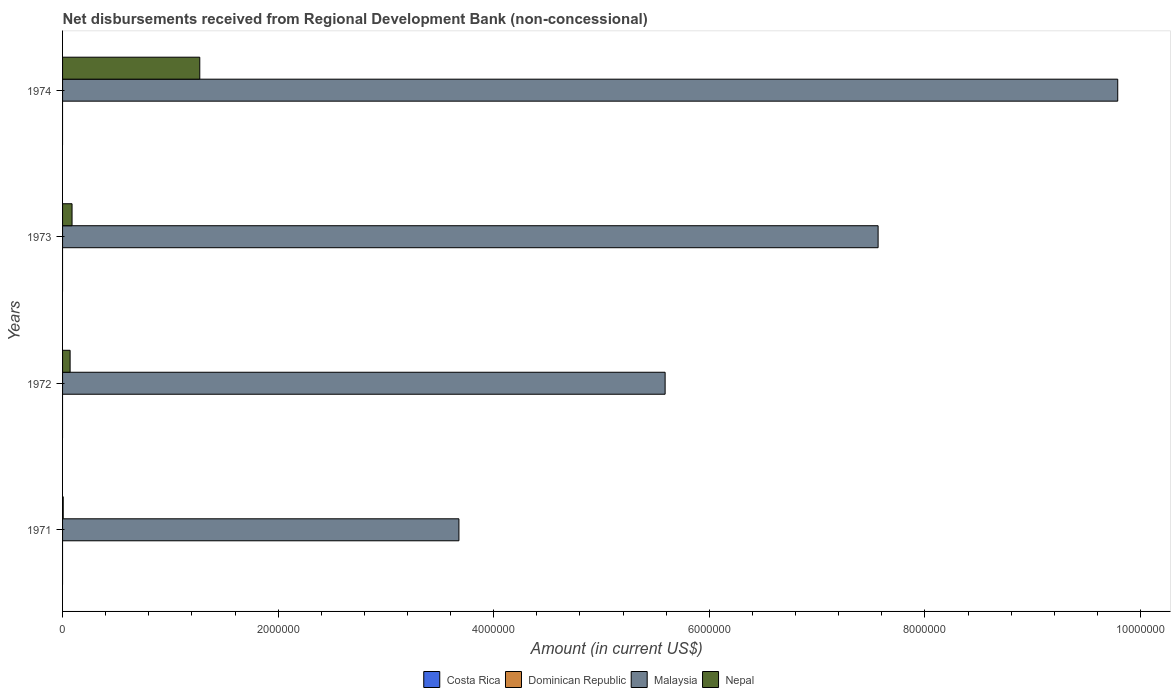How many bars are there on the 1st tick from the top?
Offer a very short reply. 2. What is the label of the 1st group of bars from the top?
Provide a short and direct response. 1974. What is the amount of disbursements received from Regional Development Bank in Nepal in 1972?
Make the answer very short. 7.00e+04. Across all years, what is the maximum amount of disbursements received from Regional Development Bank in Malaysia?
Give a very brief answer. 9.79e+06. Across all years, what is the minimum amount of disbursements received from Regional Development Bank in Costa Rica?
Give a very brief answer. 0. In which year was the amount of disbursements received from Regional Development Bank in Malaysia maximum?
Ensure brevity in your answer.  1974. What is the total amount of disbursements received from Regional Development Bank in Malaysia in the graph?
Your answer should be very brief. 2.66e+07. What is the difference between the amount of disbursements received from Regional Development Bank in Nepal in 1971 and that in 1974?
Your response must be concise. -1.27e+06. What is the difference between the amount of disbursements received from Regional Development Bank in Malaysia in 1971 and the amount of disbursements received from Regional Development Bank in Dominican Republic in 1972?
Give a very brief answer. 3.68e+06. What is the average amount of disbursements received from Regional Development Bank in Malaysia per year?
Give a very brief answer. 6.66e+06. In the year 1971, what is the difference between the amount of disbursements received from Regional Development Bank in Malaysia and amount of disbursements received from Regional Development Bank in Nepal?
Give a very brief answer. 3.67e+06. In how many years, is the amount of disbursements received from Regional Development Bank in Malaysia greater than 800000 US$?
Your answer should be very brief. 4. What is the ratio of the amount of disbursements received from Regional Development Bank in Nepal in 1972 to that in 1973?
Make the answer very short. 0.8. Is the amount of disbursements received from Regional Development Bank in Nepal in 1972 less than that in 1974?
Give a very brief answer. Yes. What is the difference between the highest and the second highest amount of disbursements received from Regional Development Bank in Nepal?
Keep it short and to the point. 1.18e+06. What is the difference between the highest and the lowest amount of disbursements received from Regional Development Bank in Nepal?
Your response must be concise. 1.27e+06. In how many years, is the amount of disbursements received from Regional Development Bank in Malaysia greater than the average amount of disbursements received from Regional Development Bank in Malaysia taken over all years?
Your response must be concise. 2. Is the sum of the amount of disbursements received from Regional Development Bank in Nepal in 1972 and 1974 greater than the maximum amount of disbursements received from Regional Development Bank in Dominican Republic across all years?
Ensure brevity in your answer.  Yes. Is it the case that in every year, the sum of the amount of disbursements received from Regional Development Bank in Dominican Republic and amount of disbursements received from Regional Development Bank in Nepal is greater than the amount of disbursements received from Regional Development Bank in Costa Rica?
Provide a succinct answer. Yes. How many years are there in the graph?
Give a very brief answer. 4. Does the graph contain grids?
Offer a very short reply. No. Where does the legend appear in the graph?
Give a very brief answer. Bottom center. What is the title of the graph?
Keep it short and to the point. Net disbursements received from Regional Development Bank (non-concessional). What is the Amount (in current US$) of Malaysia in 1971?
Give a very brief answer. 3.68e+06. What is the Amount (in current US$) in Nepal in 1971?
Ensure brevity in your answer.  6000. What is the Amount (in current US$) of Malaysia in 1972?
Keep it short and to the point. 5.59e+06. What is the Amount (in current US$) in Malaysia in 1973?
Provide a succinct answer. 7.57e+06. What is the Amount (in current US$) of Nepal in 1973?
Your response must be concise. 8.80e+04. What is the Amount (in current US$) of Costa Rica in 1974?
Ensure brevity in your answer.  0. What is the Amount (in current US$) in Malaysia in 1974?
Offer a very short reply. 9.79e+06. What is the Amount (in current US$) of Nepal in 1974?
Offer a very short reply. 1.27e+06. Across all years, what is the maximum Amount (in current US$) in Malaysia?
Your answer should be very brief. 9.79e+06. Across all years, what is the maximum Amount (in current US$) of Nepal?
Give a very brief answer. 1.27e+06. Across all years, what is the minimum Amount (in current US$) in Malaysia?
Provide a short and direct response. 3.68e+06. Across all years, what is the minimum Amount (in current US$) in Nepal?
Your answer should be very brief. 6000. What is the total Amount (in current US$) of Dominican Republic in the graph?
Offer a terse response. 0. What is the total Amount (in current US$) in Malaysia in the graph?
Your answer should be compact. 2.66e+07. What is the total Amount (in current US$) in Nepal in the graph?
Offer a terse response. 1.44e+06. What is the difference between the Amount (in current US$) in Malaysia in 1971 and that in 1972?
Give a very brief answer. -1.91e+06. What is the difference between the Amount (in current US$) of Nepal in 1971 and that in 1972?
Provide a succinct answer. -6.40e+04. What is the difference between the Amount (in current US$) in Malaysia in 1971 and that in 1973?
Your response must be concise. -3.89e+06. What is the difference between the Amount (in current US$) of Nepal in 1971 and that in 1973?
Offer a terse response. -8.20e+04. What is the difference between the Amount (in current US$) of Malaysia in 1971 and that in 1974?
Your answer should be very brief. -6.11e+06. What is the difference between the Amount (in current US$) in Nepal in 1971 and that in 1974?
Your answer should be very brief. -1.27e+06. What is the difference between the Amount (in current US$) of Malaysia in 1972 and that in 1973?
Your response must be concise. -1.98e+06. What is the difference between the Amount (in current US$) of Nepal in 1972 and that in 1973?
Provide a short and direct response. -1.80e+04. What is the difference between the Amount (in current US$) of Malaysia in 1972 and that in 1974?
Provide a succinct answer. -4.20e+06. What is the difference between the Amount (in current US$) in Nepal in 1972 and that in 1974?
Your answer should be compact. -1.20e+06. What is the difference between the Amount (in current US$) in Malaysia in 1973 and that in 1974?
Your response must be concise. -2.22e+06. What is the difference between the Amount (in current US$) of Nepal in 1973 and that in 1974?
Your response must be concise. -1.18e+06. What is the difference between the Amount (in current US$) of Malaysia in 1971 and the Amount (in current US$) of Nepal in 1972?
Offer a very short reply. 3.61e+06. What is the difference between the Amount (in current US$) of Malaysia in 1971 and the Amount (in current US$) of Nepal in 1973?
Provide a short and direct response. 3.59e+06. What is the difference between the Amount (in current US$) of Malaysia in 1971 and the Amount (in current US$) of Nepal in 1974?
Ensure brevity in your answer.  2.40e+06. What is the difference between the Amount (in current US$) in Malaysia in 1972 and the Amount (in current US$) in Nepal in 1973?
Provide a succinct answer. 5.50e+06. What is the difference between the Amount (in current US$) of Malaysia in 1972 and the Amount (in current US$) of Nepal in 1974?
Your response must be concise. 4.32e+06. What is the difference between the Amount (in current US$) in Malaysia in 1973 and the Amount (in current US$) in Nepal in 1974?
Keep it short and to the point. 6.29e+06. What is the average Amount (in current US$) of Costa Rica per year?
Your answer should be compact. 0. What is the average Amount (in current US$) in Dominican Republic per year?
Keep it short and to the point. 0. What is the average Amount (in current US$) of Malaysia per year?
Offer a terse response. 6.66e+06. What is the average Amount (in current US$) in Nepal per year?
Keep it short and to the point. 3.59e+05. In the year 1971, what is the difference between the Amount (in current US$) in Malaysia and Amount (in current US$) in Nepal?
Give a very brief answer. 3.67e+06. In the year 1972, what is the difference between the Amount (in current US$) of Malaysia and Amount (in current US$) of Nepal?
Your response must be concise. 5.52e+06. In the year 1973, what is the difference between the Amount (in current US$) in Malaysia and Amount (in current US$) in Nepal?
Ensure brevity in your answer.  7.48e+06. In the year 1974, what is the difference between the Amount (in current US$) of Malaysia and Amount (in current US$) of Nepal?
Provide a succinct answer. 8.52e+06. What is the ratio of the Amount (in current US$) of Malaysia in 1971 to that in 1972?
Your response must be concise. 0.66. What is the ratio of the Amount (in current US$) of Nepal in 1971 to that in 1972?
Give a very brief answer. 0.09. What is the ratio of the Amount (in current US$) in Malaysia in 1971 to that in 1973?
Ensure brevity in your answer.  0.49. What is the ratio of the Amount (in current US$) in Nepal in 1971 to that in 1973?
Offer a terse response. 0.07. What is the ratio of the Amount (in current US$) in Malaysia in 1971 to that in 1974?
Offer a terse response. 0.38. What is the ratio of the Amount (in current US$) in Nepal in 1971 to that in 1974?
Offer a very short reply. 0. What is the ratio of the Amount (in current US$) of Malaysia in 1972 to that in 1973?
Your answer should be very brief. 0.74. What is the ratio of the Amount (in current US$) in Nepal in 1972 to that in 1973?
Give a very brief answer. 0.8. What is the ratio of the Amount (in current US$) of Malaysia in 1972 to that in 1974?
Your response must be concise. 0.57. What is the ratio of the Amount (in current US$) of Nepal in 1972 to that in 1974?
Give a very brief answer. 0.06. What is the ratio of the Amount (in current US$) in Malaysia in 1973 to that in 1974?
Your response must be concise. 0.77. What is the ratio of the Amount (in current US$) of Nepal in 1973 to that in 1974?
Offer a terse response. 0.07. What is the difference between the highest and the second highest Amount (in current US$) in Malaysia?
Ensure brevity in your answer.  2.22e+06. What is the difference between the highest and the second highest Amount (in current US$) in Nepal?
Provide a succinct answer. 1.18e+06. What is the difference between the highest and the lowest Amount (in current US$) of Malaysia?
Make the answer very short. 6.11e+06. What is the difference between the highest and the lowest Amount (in current US$) in Nepal?
Your answer should be very brief. 1.27e+06. 